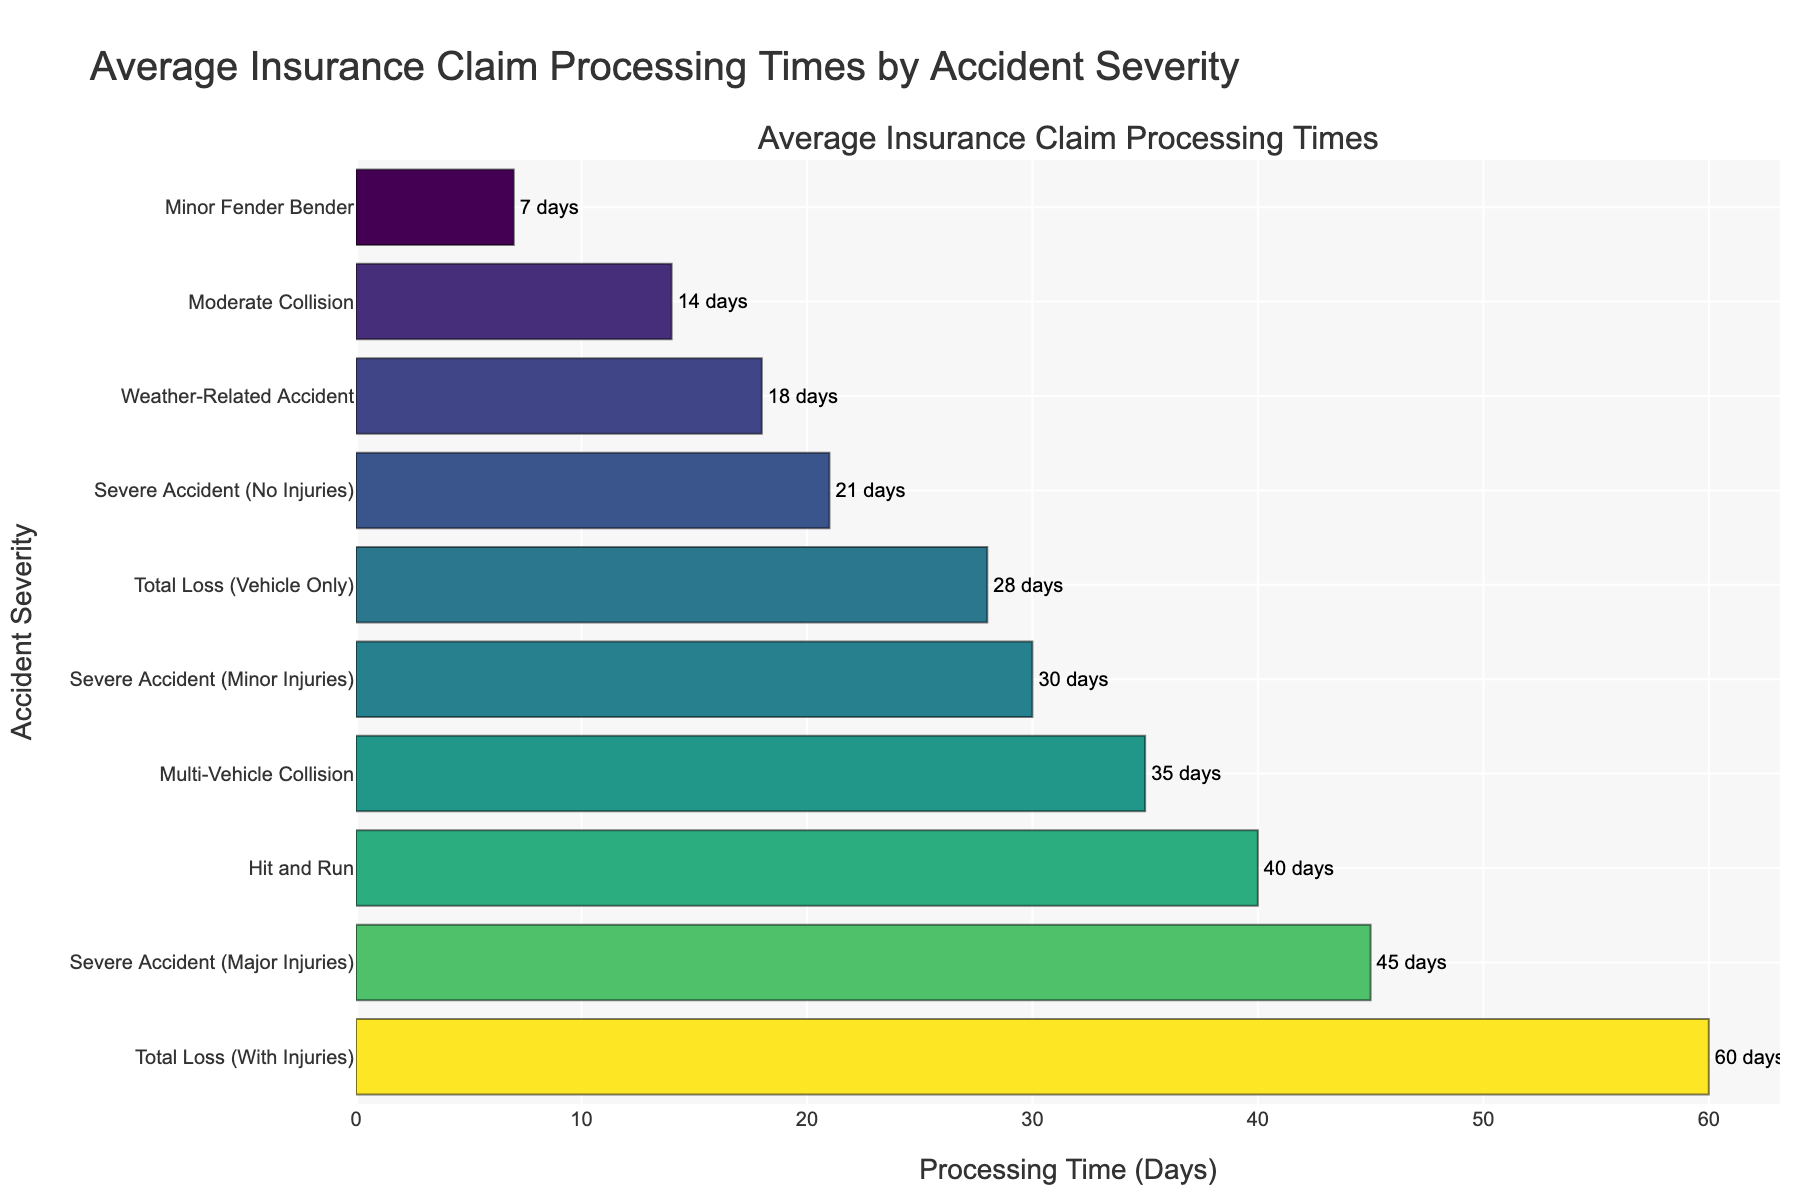What is the average processing time for a "Minor Fender Bender"? Locate the bar corresponding to "Minor Fender Bender" and read the label that shows the average processing time.
Answer: 7 days Which accident severity has the longest average processing time? Find the bar that extends the farthest to the right. The text label on this bar will indicate the accident severity with the longest processing time.
Answer: Total Loss (With Injuries) Is the processing time for "Moderate Collision" longer than for "Weather-Related Accident"? Compare the lengths of the bars for "Moderate Collision" and "Weather-Related Accident". The bar reaching further to the right indicates a longer processing time.
Answer: Yes What is the difference in processing time between "Total Loss (Vehicle Only)" and "Hit and Run"? Find the bars for "Total Loss (Vehicle Only)" and "Hit and Run", then subtract the value of "Total Loss (Vehicle Only)" from "Hit and Run" (40 - 28).
Answer: 12 days What is the total average processing time for all accident severities combined? Sum the average processing times for all listed accident severities: 7 + 14 + 21 + 30 + 45 + 28 + 60 + 35 + 40 + 18.
Answer: 298 days Which accident severities have an average processing time below 20 days? Identify the bars with values less than 20 days. These would be "Minor Fender Bender" (7), "Moderate Collision" (14), and "Weather-Related Accident" (18).
Answer: Minor Fender Bender, Moderate Collision, Weather-Related Accident How does the processing time for "Severe Accident (Minor Injuries)" compare to "Severe Accident (Major Injuries)"? Compare the lengths of the bars for "Severe Accident (Minor Injuries)" and "Severe Accident (Major Injuries)". The bar extending further indicates a longer processing time. "Severe Accident (Minor Injuries)" is shorter than "Severe Accident (Major Injuries)".
Answer: Shorter Which accident severity has the shortest processing time? Find the bar that extends the shortest distance to the right. The label on this bar will tell you the accident severity with the shortest processing time.
Answer: Minor Fender Bender If "Severe Accident (No Injuries)" is combined with "Weather-Related Accident", what would be the new average processing time? Add the averages of "Severe Accident (No Injuries)" and "Weather-Related Accident" and divide by two: (21 + 18) / 2.
Answer: 19.5 days 